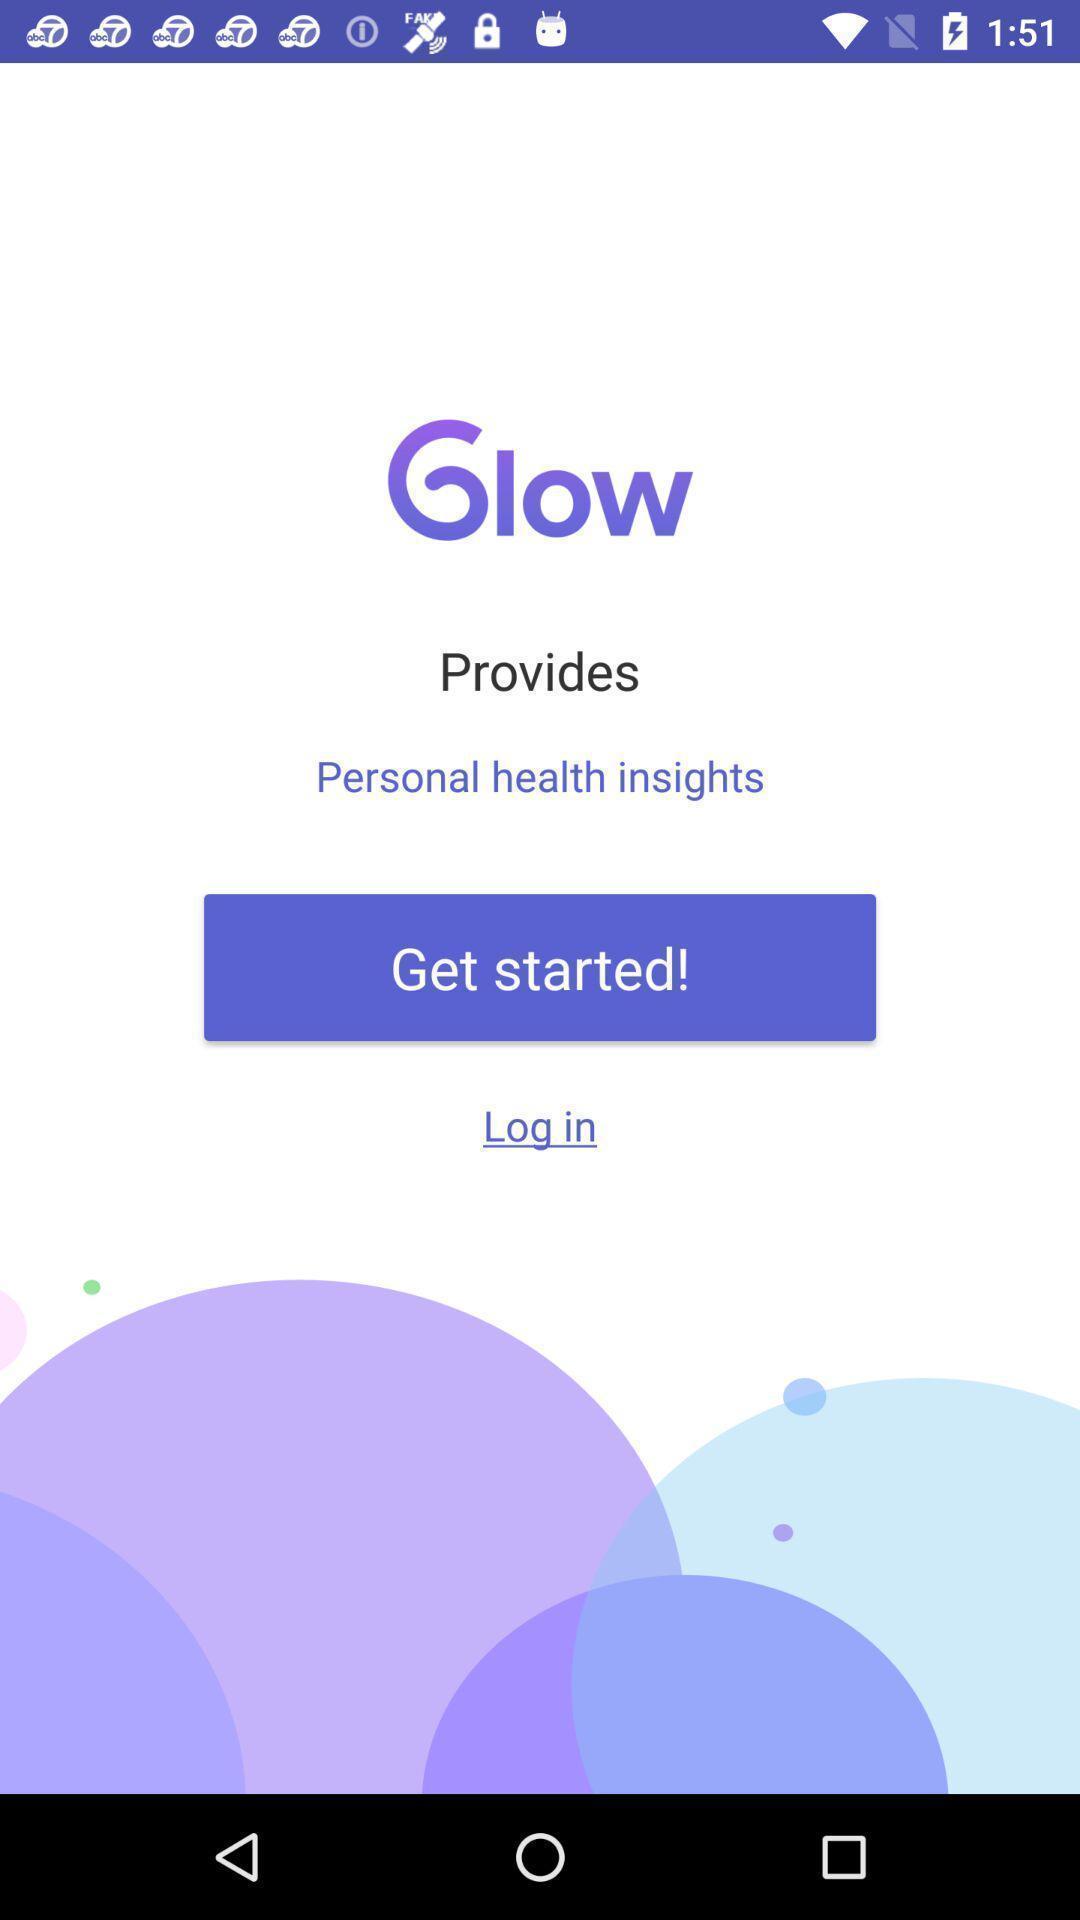What details can you identify in this image? Start page. 